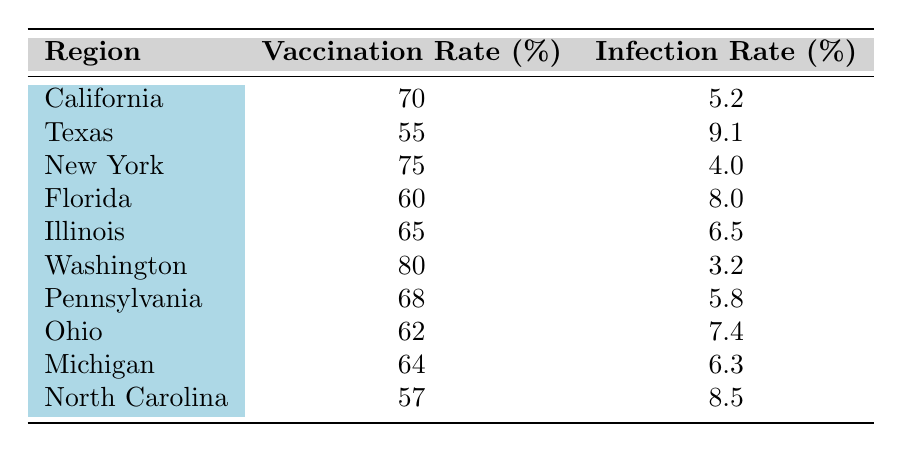What is the vaccination rate in Florida? From the table, we can see that the vaccination rate for Florida is explicitly listed. The value in the second column for Florida reads 60.
Answer: 60 What is the infection rate in New York? The infection rate for New York is found directly in the table. In the third column corresponding to New York, the value is 4.0.
Answer: 4.0 Which region has the highest vaccination rate? By examining the vaccination rate column, Washington shows the highest value at 80, making it the region with the highest vaccination rate.
Answer: Washington Is it true that Texas has a higher infection rate than California? Looking at the table, Texas has an infection rate of 9.1, while California has an infection rate of 5.2. Since 9.1 > 5.2, the statement is true.
Answer: Yes What is the average vaccination rate of all regions listed? To find the average vaccination rate, we need to sum all the vaccination rates (70 + 55 + 75 + 60 + 65 + 80 + 68 + 62 + 64 + 57) =  62.5 and divide by the number of regions (10). The average is thus 67.
Answer: 67 What is the difference in infection rates between Ohio and Pennsylvania? Ohio's infection rate is 7.4, while Pennsylvania's infection rate is 5.8. To find the difference, we subtract Pennsylvania's rate from Ohio's: 7.4 - 5.8 = 1.6.
Answer: 1.6 In which region do we find an infection rate that is less than 5? From the table, Washington has an infection rate of 3.2, which is the only rate under 5. Other regions either equal or exceed this threshold.
Answer: Washington Is the vaccination rate in North Carolina below the average vaccination rate of the regions listed? The average vaccination rate is 67. North Carolina's rate is 57, which is less than 67. Thus, it is true that North Carolina's vaccination rate is below the average.
Answer: Yes What is the combined total of vaccination rates for Texas and Illinois? Adding the vaccination rates for Texas (55) and Illinois (65) gives (55 + 65 = 120). This is the combined total for these two regions.
Answer: 120 